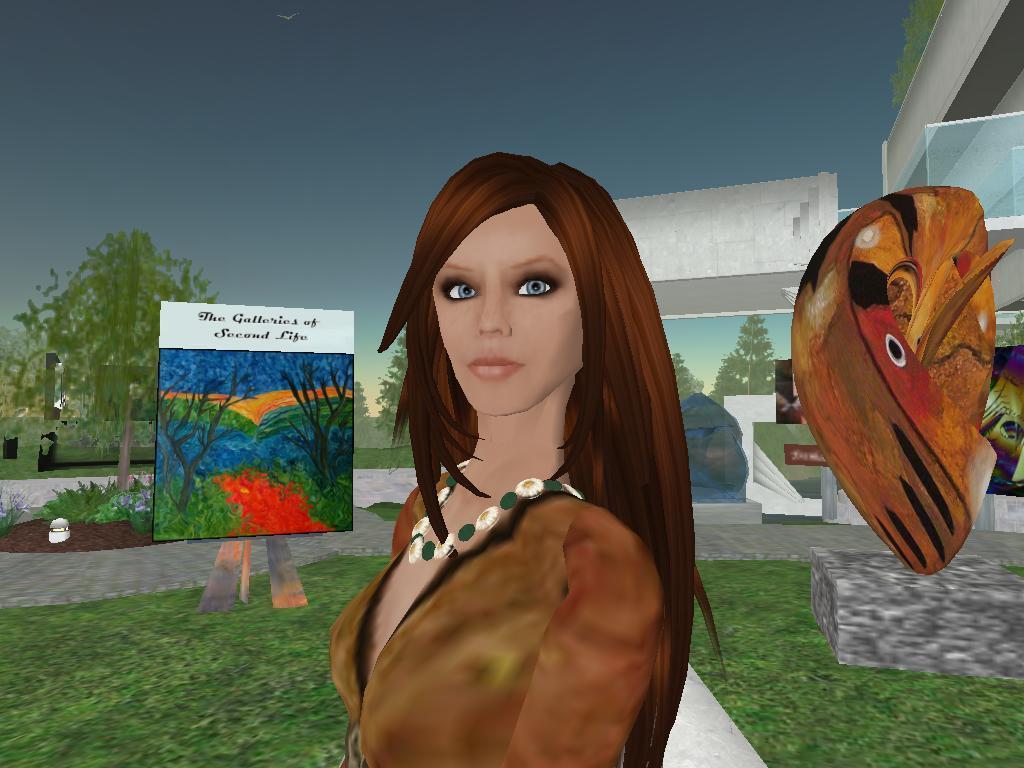How would you summarize this image in a sentence or two? This is an animated picture. In the center of the image we can see a lady is standing. In the background of the image we can see the trees, screen, plants, flowers, statue, building, wall. At the bottom of the image we can see the ground. At the top of the image we can see the sky. 